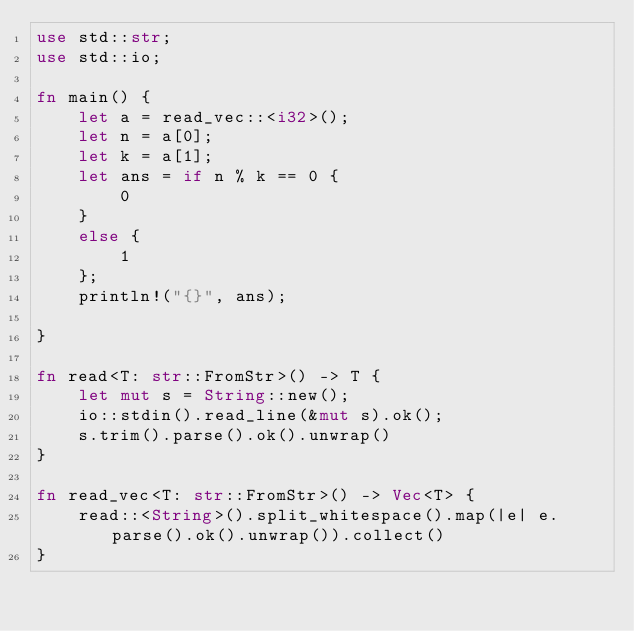<code> <loc_0><loc_0><loc_500><loc_500><_Rust_>use std::str;
use std::io;

fn main() {
    let a = read_vec::<i32>();
    let n = a[0];
    let k = a[1];
    let ans = if n % k == 0 {
        0 
    }
    else {
        1
    };
    println!("{}", ans);

}

fn read<T: str::FromStr>() -> T {
    let mut s = String::new();
    io::stdin().read_line(&mut s).ok();
    s.trim().parse().ok().unwrap()
}

fn read_vec<T: str::FromStr>() -> Vec<T> {
    read::<String>().split_whitespace().map(|e| e.parse().ok().unwrap()).collect()
}</code> 